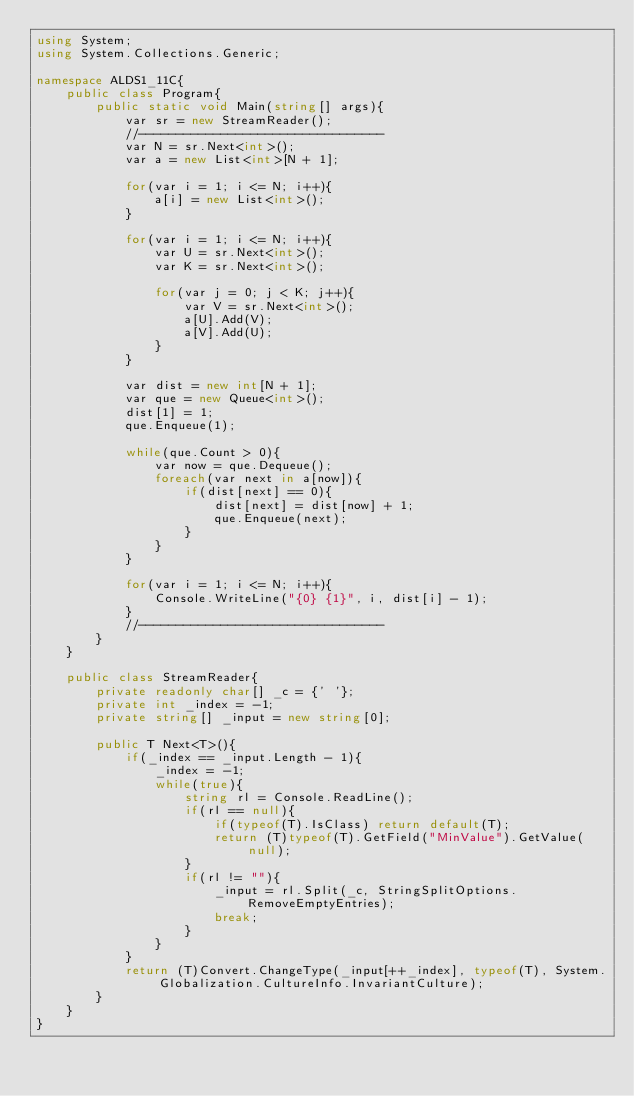<code> <loc_0><loc_0><loc_500><loc_500><_C#_>using System;
using System.Collections.Generic;

namespace ALDS1_11C{
    public class Program{
        public static void Main(string[] args){
            var sr = new StreamReader();
            //---------------------------------
            var N = sr.Next<int>();
            var a = new List<int>[N + 1];

            for(var i = 1; i <= N; i++){
                a[i] = new List<int>();
            }

            for(var i = 1; i <= N; i++){
                var U = sr.Next<int>();
                var K = sr.Next<int>();

                for(var j = 0; j < K; j++){
                    var V = sr.Next<int>();
                    a[U].Add(V);
                    a[V].Add(U);
                }
            }

            var dist = new int[N + 1];
            var que = new Queue<int>();
            dist[1] = 1;
            que.Enqueue(1);

            while(que.Count > 0){
                var now = que.Dequeue();
                foreach(var next in a[now]){
                    if(dist[next] == 0){
                        dist[next] = dist[now] + 1;
                        que.Enqueue(next);
                    }
                }
            }

            for(var i = 1; i <= N; i++){
                Console.WriteLine("{0} {1}", i, dist[i] - 1);
            }
            //---------------------------------
        }
    }

    public class StreamReader{
        private readonly char[] _c = {' '};
        private int _index = -1;
        private string[] _input = new string[0];

        public T Next<T>(){
            if(_index == _input.Length - 1){
                _index = -1;
                while(true){
                    string rl = Console.ReadLine();
                    if(rl == null){
                        if(typeof(T).IsClass) return default(T);
                        return (T)typeof(T).GetField("MinValue").GetValue(null);
                    }
                    if(rl != ""){
                        _input = rl.Split(_c, StringSplitOptions.RemoveEmptyEntries);
                        break;
                    }
                }
            }
            return (T)Convert.ChangeType(_input[++_index], typeof(T), System.Globalization.CultureInfo.InvariantCulture);
        }
    }
}</code> 